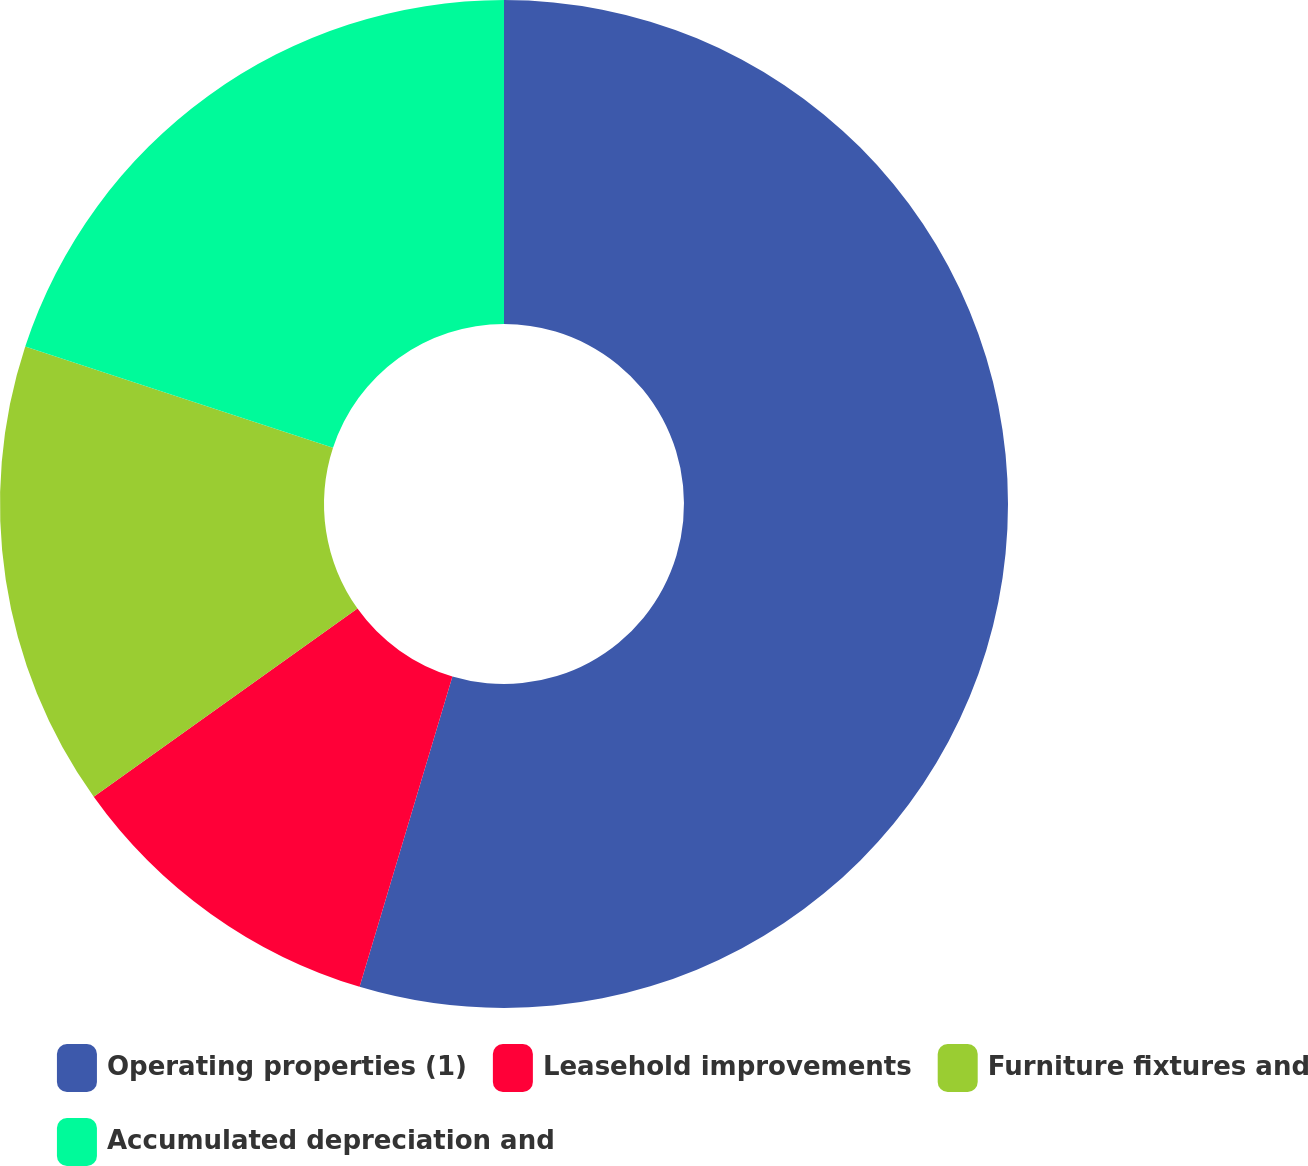Convert chart to OTSL. <chart><loc_0><loc_0><loc_500><loc_500><pie_chart><fcel>Operating properties (1)<fcel>Leasehold improvements<fcel>Furniture fixtures and<fcel>Accumulated depreciation and<nl><fcel>54.62%<fcel>10.51%<fcel>14.92%<fcel>19.94%<nl></chart> 